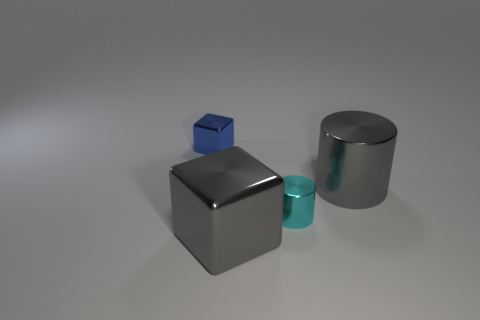Add 3 shiny spheres. How many objects exist? 7 Add 4 small metallic things. How many small metallic things exist? 6 Subtract 1 gray cylinders. How many objects are left? 3 Subtract 2 cylinders. How many cylinders are left? 0 Subtract all gray blocks. Subtract all purple cylinders. How many blocks are left? 1 Subtract all blue balls. How many purple blocks are left? 0 Subtract all blue spheres. Subtract all gray cylinders. How many objects are left? 3 Add 4 tiny things. How many tiny things are left? 6 